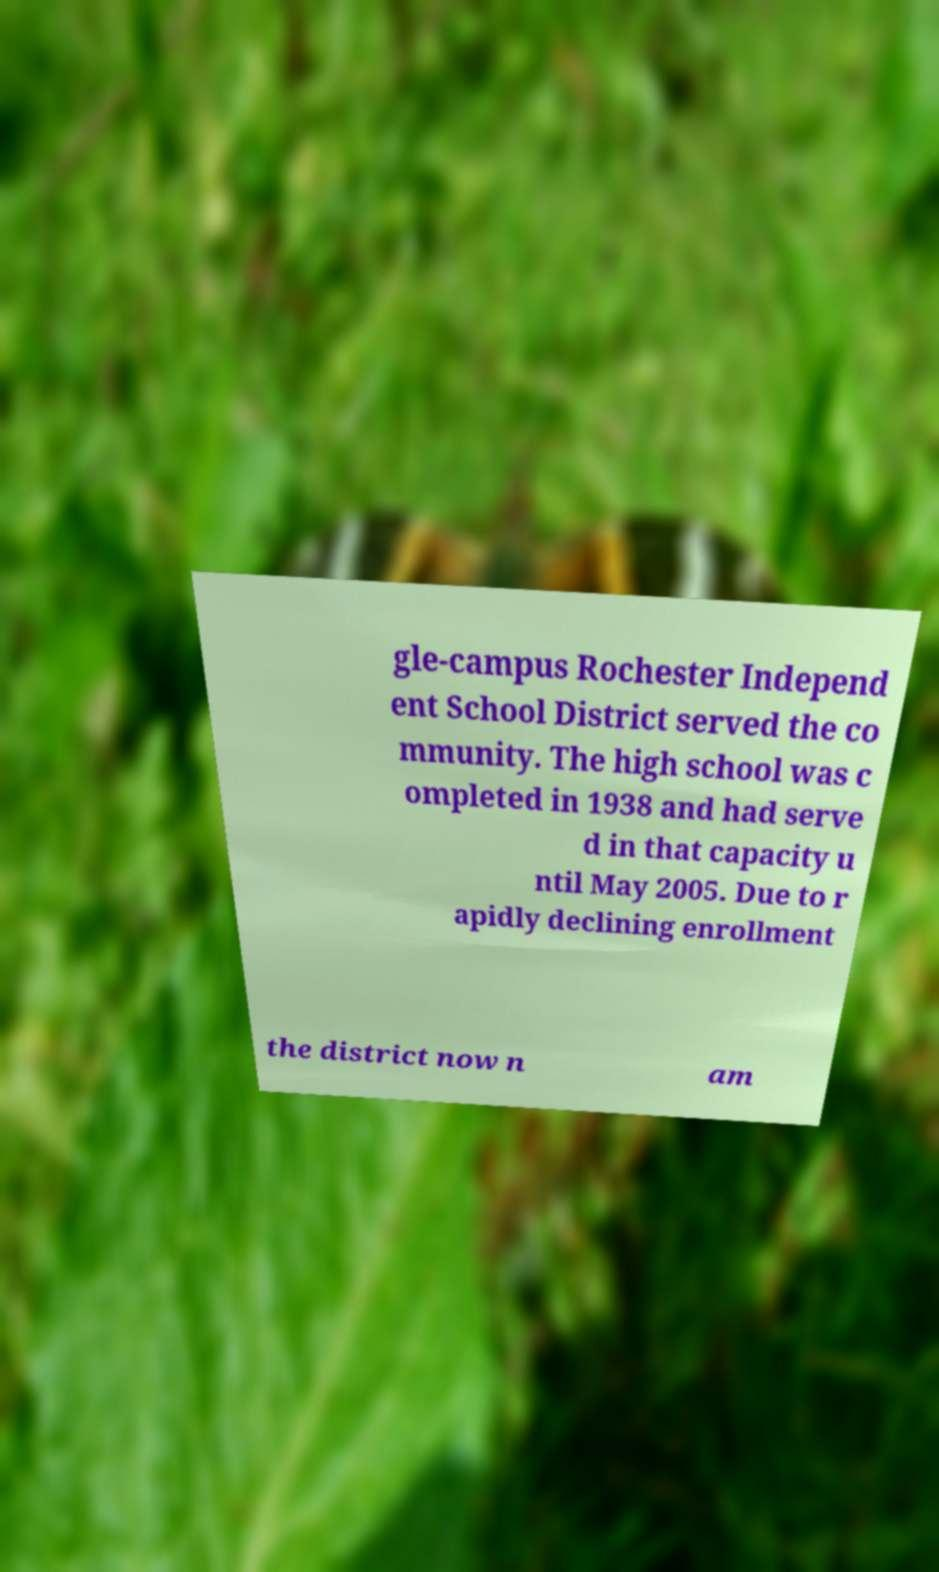Could you assist in decoding the text presented in this image and type it out clearly? gle-campus Rochester Independ ent School District served the co mmunity. The high school was c ompleted in 1938 and had serve d in that capacity u ntil May 2005. Due to r apidly declining enrollment the district now n am 